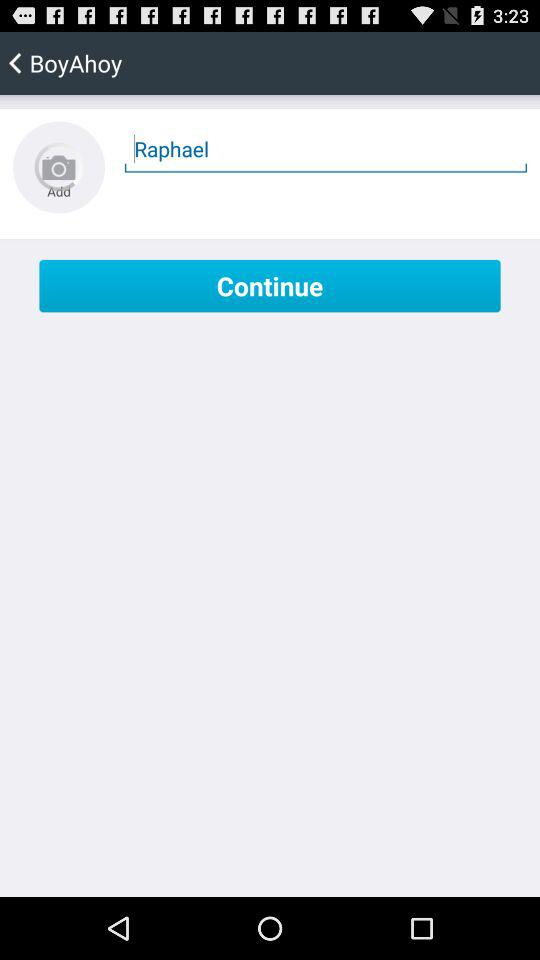Which photo is added?
When the provided information is insufficient, respond with <no answer>. <no answer> 